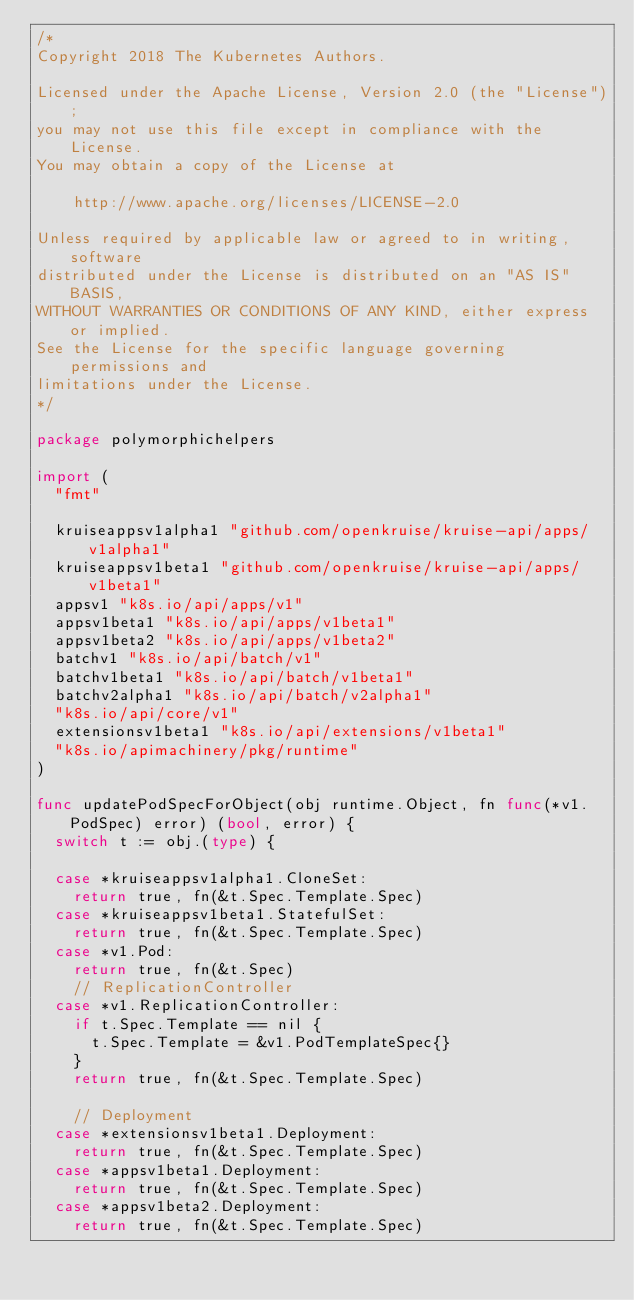<code> <loc_0><loc_0><loc_500><loc_500><_Go_>/*
Copyright 2018 The Kubernetes Authors.

Licensed under the Apache License, Version 2.0 (the "License");
you may not use this file except in compliance with the License.
You may obtain a copy of the License at

    http://www.apache.org/licenses/LICENSE-2.0

Unless required by applicable law or agreed to in writing, software
distributed under the License is distributed on an "AS IS" BASIS,
WITHOUT WARRANTIES OR CONDITIONS OF ANY KIND, either express or implied.
See the License for the specific language governing permissions and
limitations under the License.
*/

package polymorphichelpers

import (
	"fmt"

	kruiseappsv1alpha1 "github.com/openkruise/kruise-api/apps/v1alpha1"
	kruiseappsv1beta1 "github.com/openkruise/kruise-api/apps/v1beta1"
	appsv1 "k8s.io/api/apps/v1"
	appsv1beta1 "k8s.io/api/apps/v1beta1"
	appsv1beta2 "k8s.io/api/apps/v1beta2"
	batchv1 "k8s.io/api/batch/v1"
	batchv1beta1 "k8s.io/api/batch/v1beta1"
	batchv2alpha1 "k8s.io/api/batch/v2alpha1"
	"k8s.io/api/core/v1"
	extensionsv1beta1 "k8s.io/api/extensions/v1beta1"
	"k8s.io/apimachinery/pkg/runtime"
)

func updatePodSpecForObject(obj runtime.Object, fn func(*v1.PodSpec) error) (bool, error) {
	switch t := obj.(type) {

	case *kruiseappsv1alpha1.CloneSet:
		return true, fn(&t.Spec.Template.Spec)
	case *kruiseappsv1beta1.StatefulSet:
		return true, fn(&t.Spec.Template.Spec)
	case *v1.Pod:
		return true, fn(&t.Spec)
		// ReplicationController
	case *v1.ReplicationController:
		if t.Spec.Template == nil {
			t.Spec.Template = &v1.PodTemplateSpec{}
		}
		return true, fn(&t.Spec.Template.Spec)

		// Deployment
	case *extensionsv1beta1.Deployment:
		return true, fn(&t.Spec.Template.Spec)
	case *appsv1beta1.Deployment:
		return true, fn(&t.Spec.Template.Spec)
	case *appsv1beta2.Deployment:
		return true, fn(&t.Spec.Template.Spec)</code> 